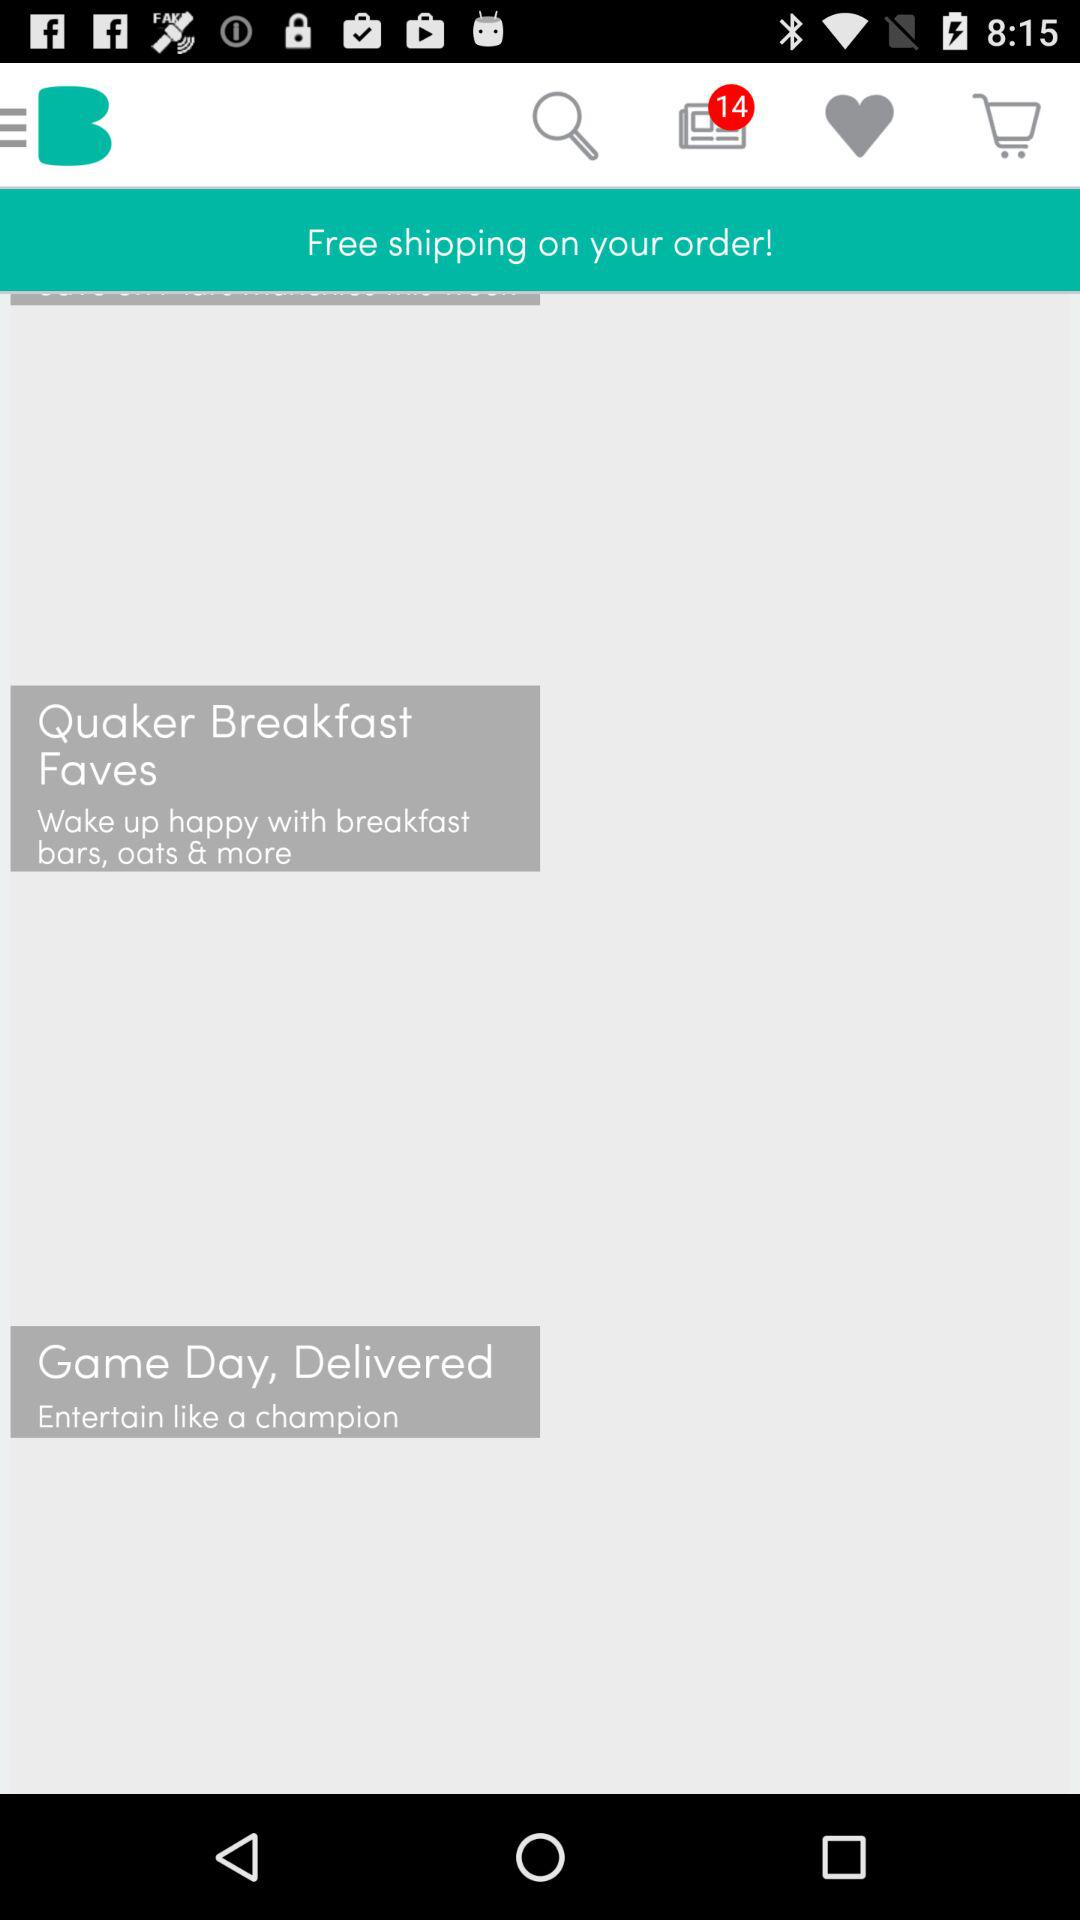Is shipping free or paid on order?
Answer the question using a single word or phrase. Shipping is free. 